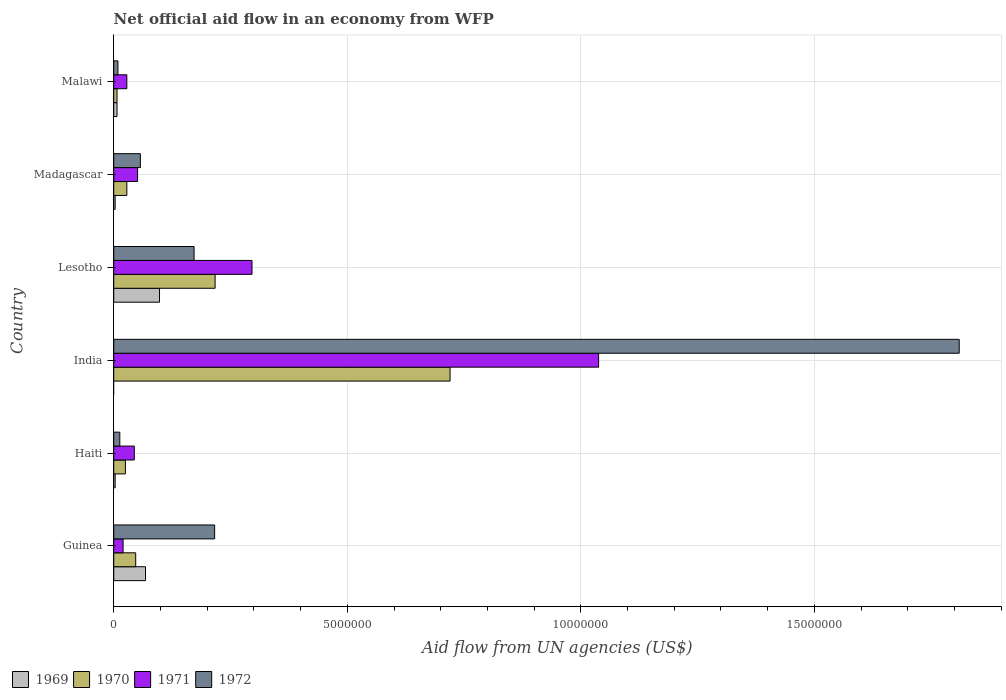Are the number of bars on each tick of the Y-axis equal?
Make the answer very short. No. How many bars are there on the 6th tick from the bottom?
Offer a terse response. 4. What is the label of the 2nd group of bars from the top?
Offer a terse response. Madagascar. In how many cases, is the number of bars for a given country not equal to the number of legend labels?
Your answer should be very brief. 1. Across all countries, what is the maximum net official aid flow in 1971?
Offer a very short reply. 1.04e+07. Across all countries, what is the minimum net official aid flow in 1970?
Provide a succinct answer. 7.00e+04. In which country was the net official aid flow in 1971 maximum?
Keep it short and to the point. India. What is the total net official aid flow in 1971 in the graph?
Your answer should be compact. 1.48e+07. What is the difference between the net official aid flow in 1972 in India and that in Malawi?
Provide a short and direct response. 1.80e+07. What is the average net official aid flow in 1972 per country?
Offer a terse response. 3.80e+06. What is the difference between the net official aid flow in 1971 and net official aid flow in 1972 in Guinea?
Your answer should be compact. -1.96e+06. What is the ratio of the net official aid flow in 1969 in Madagascar to that in Malawi?
Ensure brevity in your answer.  0.43. Is the net official aid flow in 1970 in Guinea less than that in Malawi?
Ensure brevity in your answer.  No. What is the difference between the highest and the second highest net official aid flow in 1972?
Your answer should be very brief. 1.59e+07. What is the difference between the highest and the lowest net official aid flow in 1969?
Your answer should be compact. 9.80e+05. How many countries are there in the graph?
Give a very brief answer. 6. Are the values on the major ticks of X-axis written in scientific E-notation?
Ensure brevity in your answer.  No. Does the graph contain grids?
Offer a terse response. Yes. How are the legend labels stacked?
Ensure brevity in your answer.  Horizontal. What is the title of the graph?
Offer a very short reply. Net official aid flow in an economy from WFP. Does "1972" appear as one of the legend labels in the graph?
Offer a terse response. Yes. What is the label or title of the X-axis?
Make the answer very short. Aid flow from UN agencies (US$). What is the Aid flow from UN agencies (US$) in 1969 in Guinea?
Provide a succinct answer. 6.80e+05. What is the Aid flow from UN agencies (US$) of 1971 in Guinea?
Your answer should be very brief. 2.00e+05. What is the Aid flow from UN agencies (US$) of 1972 in Guinea?
Provide a succinct answer. 2.16e+06. What is the Aid flow from UN agencies (US$) in 1969 in Haiti?
Make the answer very short. 3.00e+04. What is the Aid flow from UN agencies (US$) in 1971 in Haiti?
Keep it short and to the point. 4.40e+05. What is the Aid flow from UN agencies (US$) of 1972 in Haiti?
Make the answer very short. 1.30e+05. What is the Aid flow from UN agencies (US$) in 1969 in India?
Your answer should be compact. 0. What is the Aid flow from UN agencies (US$) of 1970 in India?
Make the answer very short. 7.20e+06. What is the Aid flow from UN agencies (US$) in 1971 in India?
Offer a very short reply. 1.04e+07. What is the Aid flow from UN agencies (US$) in 1972 in India?
Your answer should be compact. 1.81e+07. What is the Aid flow from UN agencies (US$) in 1969 in Lesotho?
Provide a short and direct response. 9.80e+05. What is the Aid flow from UN agencies (US$) in 1970 in Lesotho?
Your answer should be compact. 2.17e+06. What is the Aid flow from UN agencies (US$) in 1971 in Lesotho?
Ensure brevity in your answer.  2.96e+06. What is the Aid flow from UN agencies (US$) in 1972 in Lesotho?
Provide a short and direct response. 1.72e+06. What is the Aid flow from UN agencies (US$) of 1969 in Madagascar?
Your answer should be compact. 3.00e+04. What is the Aid flow from UN agencies (US$) of 1971 in Madagascar?
Ensure brevity in your answer.  5.10e+05. What is the Aid flow from UN agencies (US$) in 1972 in Madagascar?
Your answer should be compact. 5.70e+05. What is the Aid flow from UN agencies (US$) of 1970 in Malawi?
Ensure brevity in your answer.  7.00e+04. Across all countries, what is the maximum Aid flow from UN agencies (US$) in 1969?
Make the answer very short. 9.80e+05. Across all countries, what is the maximum Aid flow from UN agencies (US$) in 1970?
Ensure brevity in your answer.  7.20e+06. Across all countries, what is the maximum Aid flow from UN agencies (US$) in 1971?
Your response must be concise. 1.04e+07. Across all countries, what is the maximum Aid flow from UN agencies (US$) of 1972?
Your answer should be very brief. 1.81e+07. Across all countries, what is the minimum Aid flow from UN agencies (US$) of 1970?
Give a very brief answer. 7.00e+04. Across all countries, what is the minimum Aid flow from UN agencies (US$) of 1972?
Give a very brief answer. 9.00e+04. What is the total Aid flow from UN agencies (US$) of 1969 in the graph?
Keep it short and to the point. 1.79e+06. What is the total Aid flow from UN agencies (US$) in 1970 in the graph?
Make the answer very short. 1.04e+07. What is the total Aid flow from UN agencies (US$) in 1971 in the graph?
Ensure brevity in your answer.  1.48e+07. What is the total Aid flow from UN agencies (US$) of 1972 in the graph?
Offer a terse response. 2.28e+07. What is the difference between the Aid flow from UN agencies (US$) of 1969 in Guinea and that in Haiti?
Your answer should be compact. 6.50e+05. What is the difference between the Aid flow from UN agencies (US$) of 1970 in Guinea and that in Haiti?
Keep it short and to the point. 2.20e+05. What is the difference between the Aid flow from UN agencies (US$) of 1971 in Guinea and that in Haiti?
Your answer should be very brief. -2.40e+05. What is the difference between the Aid flow from UN agencies (US$) in 1972 in Guinea and that in Haiti?
Your answer should be compact. 2.03e+06. What is the difference between the Aid flow from UN agencies (US$) in 1970 in Guinea and that in India?
Offer a very short reply. -6.73e+06. What is the difference between the Aid flow from UN agencies (US$) of 1971 in Guinea and that in India?
Offer a terse response. -1.02e+07. What is the difference between the Aid flow from UN agencies (US$) in 1972 in Guinea and that in India?
Provide a succinct answer. -1.59e+07. What is the difference between the Aid flow from UN agencies (US$) in 1969 in Guinea and that in Lesotho?
Provide a succinct answer. -3.00e+05. What is the difference between the Aid flow from UN agencies (US$) in 1970 in Guinea and that in Lesotho?
Offer a very short reply. -1.70e+06. What is the difference between the Aid flow from UN agencies (US$) of 1971 in Guinea and that in Lesotho?
Make the answer very short. -2.76e+06. What is the difference between the Aid flow from UN agencies (US$) of 1972 in Guinea and that in Lesotho?
Ensure brevity in your answer.  4.40e+05. What is the difference between the Aid flow from UN agencies (US$) of 1969 in Guinea and that in Madagascar?
Your answer should be very brief. 6.50e+05. What is the difference between the Aid flow from UN agencies (US$) of 1970 in Guinea and that in Madagascar?
Offer a terse response. 1.90e+05. What is the difference between the Aid flow from UN agencies (US$) in 1971 in Guinea and that in Madagascar?
Offer a very short reply. -3.10e+05. What is the difference between the Aid flow from UN agencies (US$) in 1972 in Guinea and that in Madagascar?
Your answer should be compact. 1.59e+06. What is the difference between the Aid flow from UN agencies (US$) of 1969 in Guinea and that in Malawi?
Keep it short and to the point. 6.10e+05. What is the difference between the Aid flow from UN agencies (US$) of 1970 in Guinea and that in Malawi?
Ensure brevity in your answer.  4.00e+05. What is the difference between the Aid flow from UN agencies (US$) of 1971 in Guinea and that in Malawi?
Make the answer very short. -8.00e+04. What is the difference between the Aid flow from UN agencies (US$) of 1972 in Guinea and that in Malawi?
Provide a succinct answer. 2.07e+06. What is the difference between the Aid flow from UN agencies (US$) of 1970 in Haiti and that in India?
Your answer should be very brief. -6.95e+06. What is the difference between the Aid flow from UN agencies (US$) of 1971 in Haiti and that in India?
Offer a very short reply. -9.94e+06. What is the difference between the Aid flow from UN agencies (US$) of 1972 in Haiti and that in India?
Give a very brief answer. -1.80e+07. What is the difference between the Aid flow from UN agencies (US$) of 1969 in Haiti and that in Lesotho?
Ensure brevity in your answer.  -9.50e+05. What is the difference between the Aid flow from UN agencies (US$) of 1970 in Haiti and that in Lesotho?
Keep it short and to the point. -1.92e+06. What is the difference between the Aid flow from UN agencies (US$) of 1971 in Haiti and that in Lesotho?
Make the answer very short. -2.52e+06. What is the difference between the Aid flow from UN agencies (US$) of 1972 in Haiti and that in Lesotho?
Your answer should be very brief. -1.59e+06. What is the difference between the Aid flow from UN agencies (US$) of 1972 in Haiti and that in Madagascar?
Your answer should be compact. -4.40e+05. What is the difference between the Aid flow from UN agencies (US$) of 1970 in Haiti and that in Malawi?
Your response must be concise. 1.80e+05. What is the difference between the Aid flow from UN agencies (US$) in 1970 in India and that in Lesotho?
Offer a terse response. 5.03e+06. What is the difference between the Aid flow from UN agencies (US$) of 1971 in India and that in Lesotho?
Give a very brief answer. 7.42e+06. What is the difference between the Aid flow from UN agencies (US$) in 1972 in India and that in Lesotho?
Ensure brevity in your answer.  1.64e+07. What is the difference between the Aid flow from UN agencies (US$) in 1970 in India and that in Madagascar?
Provide a short and direct response. 6.92e+06. What is the difference between the Aid flow from UN agencies (US$) in 1971 in India and that in Madagascar?
Make the answer very short. 9.87e+06. What is the difference between the Aid flow from UN agencies (US$) in 1972 in India and that in Madagascar?
Your answer should be very brief. 1.75e+07. What is the difference between the Aid flow from UN agencies (US$) of 1970 in India and that in Malawi?
Provide a succinct answer. 7.13e+06. What is the difference between the Aid flow from UN agencies (US$) of 1971 in India and that in Malawi?
Offer a very short reply. 1.01e+07. What is the difference between the Aid flow from UN agencies (US$) in 1972 in India and that in Malawi?
Keep it short and to the point. 1.80e+07. What is the difference between the Aid flow from UN agencies (US$) in 1969 in Lesotho and that in Madagascar?
Your response must be concise. 9.50e+05. What is the difference between the Aid flow from UN agencies (US$) in 1970 in Lesotho and that in Madagascar?
Your answer should be compact. 1.89e+06. What is the difference between the Aid flow from UN agencies (US$) of 1971 in Lesotho and that in Madagascar?
Your answer should be very brief. 2.45e+06. What is the difference between the Aid flow from UN agencies (US$) of 1972 in Lesotho and that in Madagascar?
Ensure brevity in your answer.  1.15e+06. What is the difference between the Aid flow from UN agencies (US$) of 1969 in Lesotho and that in Malawi?
Offer a terse response. 9.10e+05. What is the difference between the Aid flow from UN agencies (US$) of 1970 in Lesotho and that in Malawi?
Provide a short and direct response. 2.10e+06. What is the difference between the Aid flow from UN agencies (US$) in 1971 in Lesotho and that in Malawi?
Provide a succinct answer. 2.68e+06. What is the difference between the Aid flow from UN agencies (US$) of 1972 in Lesotho and that in Malawi?
Offer a terse response. 1.63e+06. What is the difference between the Aid flow from UN agencies (US$) in 1970 in Madagascar and that in Malawi?
Give a very brief answer. 2.10e+05. What is the difference between the Aid flow from UN agencies (US$) of 1972 in Madagascar and that in Malawi?
Provide a short and direct response. 4.80e+05. What is the difference between the Aid flow from UN agencies (US$) in 1969 in Guinea and the Aid flow from UN agencies (US$) in 1970 in Haiti?
Your answer should be very brief. 4.30e+05. What is the difference between the Aid flow from UN agencies (US$) of 1970 in Guinea and the Aid flow from UN agencies (US$) of 1971 in Haiti?
Your response must be concise. 3.00e+04. What is the difference between the Aid flow from UN agencies (US$) in 1970 in Guinea and the Aid flow from UN agencies (US$) in 1972 in Haiti?
Provide a short and direct response. 3.40e+05. What is the difference between the Aid flow from UN agencies (US$) of 1971 in Guinea and the Aid flow from UN agencies (US$) of 1972 in Haiti?
Provide a succinct answer. 7.00e+04. What is the difference between the Aid flow from UN agencies (US$) in 1969 in Guinea and the Aid flow from UN agencies (US$) in 1970 in India?
Ensure brevity in your answer.  -6.52e+06. What is the difference between the Aid flow from UN agencies (US$) in 1969 in Guinea and the Aid flow from UN agencies (US$) in 1971 in India?
Provide a short and direct response. -9.70e+06. What is the difference between the Aid flow from UN agencies (US$) in 1969 in Guinea and the Aid flow from UN agencies (US$) in 1972 in India?
Your response must be concise. -1.74e+07. What is the difference between the Aid flow from UN agencies (US$) in 1970 in Guinea and the Aid flow from UN agencies (US$) in 1971 in India?
Provide a succinct answer. -9.91e+06. What is the difference between the Aid flow from UN agencies (US$) of 1970 in Guinea and the Aid flow from UN agencies (US$) of 1972 in India?
Your response must be concise. -1.76e+07. What is the difference between the Aid flow from UN agencies (US$) of 1971 in Guinea and the Aid flow from UN agencies (US$) of 1972 in India?
Give a very brief answer. -1.79e+07. What is the difference between the Aid flow from UN agencies (US$) in 1969 in Guinea and the Aid flow from UN agencies (US$) in 1970 in Lesotho?
Your answer should be very brief. -1.49e+06. What is the difference between the Aid flow from UN agencies (US$) of 1969 in Guinea and the Aid flow from UN agencies (US$) of 1971 in Lesotho?
Give a very brief answer. -2.28e+06. What is the difference between the Aid flow from UN agencies (US$) in 1969 in Guinea and the Aid flow from UN agencies (US$) in 1972 in Lesotho?
Offer a terse response. -1.04e+06. What is the difference between the Aid flow from UN agencies (US$) of 1970 in Guinea and the Aid flow from UN agencies (US$) of 1971 in Lesotho?
Your answer should be very brief. -2.49e+06. What is the difference between the Aid flow from UN agencies (US$) of 1970 in Guinea and the Aid flow from UN agencies (US$) of 1972 in Lesotho?
Provide a succinct answer. -1.25e+06. What is the difference between the Aid flow from UN agencies (US$) in 1971 in Guinea and the Aid flow from UN agencies (US$) in 1972 in Lesotho?
Offer a terse response. -1.52e+06. What is the difference between the Aid flow from UN agencies (US$) in 1969 in Guinea and the Aid flow from UN agencies (US$) in 1970 in Madagascar?
Your answer should be compact. 4.00e+05. What is the difference between the Aid flow from UN agencies (US$) in 1970 in Guinea and the Aid flow from UN agencies (US$) in 1971 in Madagascar?
Give a very brief answer. -4.00e+04. What is the difference between the Aid flow from UN agencies (US$) in 1970 in Guinea and the Aid flow from UN agencies (US$) in 1972 in Madagascar?
Your answer should be compact. -1.00e+05. What is the difference between the Aid flow from UN agencies (US$) in 1971 in Guinea and the Aid flow from UN agencies (US$) in 1972 in Madagascar?
Keep it short and to the point. -3.70e+05. What is the difference between the Aid flow from UN agencies (US$) of 1969 in Guinea and the Aid flow from UN agencies (US$) of 1972 in Malawi?
Offer a terse response. 5.90e+05. What is the difference between the Aid flow from UN agencies (US$) in 1970 in Guinea and the Aid flow from UN agencies (US$) in 1972 in Malawi?
Give a very brief answer. 3.80e+05. What is the difference between the Aid flow from UN agencies (US$) of 1971 in Guinea and the Aid flow from UN agencies (US$) of 1972 in Malawi?
Provide a succinct answer. 1.10e+05. What is the difference between the Aid flow from UN agencies (US$) of 1969 in Haiti and the Aid flow from UN agencies (US$) of 1970 in India?
Provide a short and direct response. -7.17e+06. What is the difference between the Aid flow from UN agencies (US$) in 1969 in Haiti and the Aid flow from UN agencies (US$) in 1971 in India?
Offer a terse response. -1.04e+07. What is the difference between the Aid flow from UN agencies (US$) of 1969 in Haiti and the Aid flow from UN agencies (US$) of 1972 in India?
Your answer should be very brief. -1.81e+07. What is the difference between the Aid flow from UN agencies (US$) of 1970 in Haiti and the Aid flow from UN agencies (US$) of 1971 in India?
Give a very brief answer. -1.01e+07. What is the difference between the Aid flow from UN agencies (US$) in 1970 in Haiti and the Aid flow from UN agencies (US$) in 1972 in India?
Provide a short and direct response. -1.78e+07. What is the difference between the Aid flow from UN agencies (US$) of 1971 in Haiti and the Aid flow from UN agencies (US$) of 1972 in India?
Give a very brief answer. -1.77e+07. What is the difference between the Aid flow from UN agencies (US$) of 1969 in Haiti and the Aid flow from UN agencies (US$) of 1970 in Lesotho?
Your answer should be very brief. -2.14e+06. What is the difference between the Aid flow from UN agencies (US$) of 1969 in Haiti and the Aid flow from UN agencies (US$) of 1971 in Lesotho?
Your response must be concise. -2.93e+06. What is the difference between the Aid flow from UN agencies (US$) in 1969 in Haiti and the Aid flow from UN agencies (US$) in 1972 in Lesotho?
Provide a short and direct response. -1.69e+06. What is the difference between the Aid flow from UN agencies (US$) of 1970 in Haiti and the Aid flow from UN agencies (US$) of 1971 in Lesotho?
Your response must be concise. -2.71e+06. What is the difference between the Aid flow from UN agencies (US$) in 1970 in Haiti and the Aid flow from UN agencies (US$) in 1972 in Lesotho?
Ensure brevity in your answer.  -1.47e+06. What is the difference between the Aid flow from UN agencies (US$) in 1971 in Haiti and the Aid flow from UN agencies (US$) in 1972 in Lesotho?
Keep it short and to the point. -1.28e+06. What is the difference between the Aid flow from UN agencies (US$) of 1969 in Haiti and the Aid flow from UN agencies (US$) of 1971 in Madagascar?
Your answer should be very brief. -4.80e+05. What is the difference between the Aid flow from UN agencies (US$) of 1969 in Haiti and the Aid flow from UN agencies (US$) of 1972 in Madagascar?
Your answer should be compact. -5.40e+05. What is the difference between the Aid flow from UN agencies (US$) in 1970 in Haiti and the Aid flow from UN agencies (US$) in 1972 in Madagascar?
Offer a very short reply. -3.20e+05. What is the difference between the Aid flow from UN agencies (US$) in 1971 in Haiti and the Aid flow from UN agencies (US$) in 1972 in Madagascar?
Your answer should be very brief. -1.30e+05. What is the difference between the Aid flow from UN agencies (US$) in 1969 in Haiti and the Aid flow from UN agencies (US$) in 1971 in Malawi?
Ensure brevity in your answer.  -2.50e+05. What is the difference between the Aid flow from UN agencies (US$) in 1969 in Haiti and the Aid flow from UN agencies (US$) in 1972 in Malawi?
Provide a short and direct response. -6.00e+04. What is the difference between the Aid flow from UN agencies (US$) in 1970 in Haiti and the Aid flow from UN agencies (US$) in 1972 in Malawi?
Provide a short and direct response. 1.60e+05. What is the difference between the Aid flow from UN agencies (US$) of 1970 in India and the Aid flow from UN agencies (US$) of 1971 in Lesotho?
Provide a succinct answer. 4.24e+06. What is the difference between the Aid flow from UN agencies (US$) of 1970 in India and the Aid flow from UN agencies (US$) of 1972 in Lesotho?
Provide a succinct answer. 5.48e+06. What is the difference between the Aid flow from UN agencies (US$) in 1971 in India and the Aid flow from UN agencies (US$) in 1972 in Lesotho?
Offer a terse response. 8.66e+06. What is the difference between the Aid flow from UN agencies (US$) in 1970 in India and the Aid flow from UN agencies (US$) in 1971 in Madagascar?
Your answer should be very brief. 6.69e+06. What is the difference between the Aid flow from UN agencies (US$) of 1970 in India and the Aid flow from UN agencies (US$) of 1972 in Madagascar?
Ensure brevity in your answer.  6.63e+06. What is the difference between the Aid flow from UN agencies (US$) in 1971 in India and the Aid flow from UN agencies (US$) in 1972 in Madagascar?
Make the answer very short. 9.81e+06. What is the difference between the Aid flow from UN agencies (US$) in 1970 in India and the Aid flow from UN agencies (US$) in 1971 in Malawi?
Give a very brief answer. 6.92e+06. What is the difference between the Aid flow from UN agencies (US$) in 1970 in India and the Aid flow from UN agencies (US$) in 1972 in Malawi?
Your answer should be very brief. 7.11e+06. What is the difference between the Aid flow from UN agencies (US$) in 1971 in India and the Aid flow from UN agencies (US$) in 1972 in Malawi?
Offer a very short reply. 1.03e+07. What is the difference between the Aid flow from UN agencies (US$) of 1969 in Lesotho and the Aid flow from UN agencies (US$) of 1970 in Madagascar?
Provide a short and direct response. 7.00e+05. What is the difference between the Aid flow from UN agencies (US$) in 1970 in Lesotho and the Aid flow from UN agencies (US$) in 1971 in Madagascar?
Your answer should be very brief. 1.66e+06. What is the difference between the Aid flow from UN agencies (US$) of 1970 in Lesotho and the Aid flow from UN agencies (US$) of 1972 in Madagascar?
Offer a very short reply. 1.60e+06. What is the difference between the Aid flow from UN agencies (US$) in 1971 in Lesotho and the Aid flow from UN agencies (US$) in 1972 in Madagascar?
Your answer should be very brief. 2.39e+06. What is the difference between the Aid flow from UN agencies (US$) of 1969 in Lesotho and the Aid flow from UN agencies (US$) of 1970 in Malawi?
Your answer should be very brief. 9.10e+05. What is the difference between the Aid flow from UN agencies (US$) in 1969 in Lesotho and the Aid flow from UN agencies (US$) in 1971 in Malawi?
Provide a succinct answer. 7.00e+05. What is the difference between the Aid flow from UN agencies (US$) of 1969 in Lesotho and the Aid flow from UN agencies (US$) of 1972 in Malawi?
Offer a terse response. 8.90e+05. What is the difference between the Aid flow from UN agencies (US$) in 1970 in Lesotho and the Aid flow from UN agencies (US$) in 1971 in Malawi?
Offer a very short reply. 1.89e+06. What is the difference between the Aid flow from UN agencies (US$) of 1970 in Lesotho and the Aid flow from UN agencies (US$) of 1972 in Malawi?
Keep it short and to the point. 2.08e+06. What is the difference between the Aid flow from UN agencies (US$) of 1971 in Lesotho and the Aid flow from UN agencies (US$) of 1972 in Malawi?
Offer a very short reply. 2.87e+06. What is the difference between the Aid flow from UN agencies (US$) in 1969 in Madagascar and the Aid flow from UN agencies (US$) in 1970 in Malawi?
Your response must be concise. -4.00e+04. What is the difference between the Aid flow from UN agencies (US$) of 1969 in Madagascar and the Aid flow from UN agencies (US$) of 1971 in Malawi?
Offer a very short reply. -2.50e+05. What is the difference between the Aid flow from UN agencies (US$) of 1970 in Madagascar and the Aid flow from UN agencies (US$) of 1971 in Malawi?
Offer a terse response. 0. What is the difference between the Aid flow from UN agencies (US$) in 1970 in Madagascar and the Aid flow from UN agencies (US$) in 1972 in Malawi?
Your answer should be very brief. 1.90e+05. What is the average Aid flow from UN agencies (US$) in 1969 per country?
Ensure brevity in your answer.  2.98e+05. What is the average Aid flow from UN agencies (US$) of 1970 per country?
Provide a succinct answer. 1.74e+06. What is the average Aid flow from UN agencies (US$) of 1971 per country?
Keep it short and to the point. 2.46e+06. What is the average Aid flow from UN agencies (US$) of 1972 per country?
Ensure brevity in your answer.  3.80e+06. What is the difference between the Aid flow from UN agencies (US$) in 1969 and Aid flow from UN agencies (US$) in 1972 in Guinea?
Provide a short and direct response. -1.48e+06. What is the difference between the Aid flow from UN agencies (US$) of 1970 and Aid flow from UN agencies (US$) of 1971 in Guinea?
Your answer should be compact. 2.70e+05. What is the difference between the Aid flow from UN agencies (US$) in 1970 and Aid flow from UN agencies (US$) in 1972 in Guinea?
Your answer should be compact. -1.69e+06. What is the difference between the Aid flow from UN agencies (US$) of 1971 and Aid flow from UN agencies (US$) of 1972 in Guinea?
Give a very brief answer. -1.96e+06. What is the difference between the Aid flow from UN agencies (US$) in 1969 and Aid flow from UN agencies (US$) in 1970 in Haiti?
Offer a terse response. -2.20e+05. What is the difference between the Aid flow from UN agencies (US$) of 1969 and Aid flow from UN agencies (US$) of 1971 in Haiti?
Your answer should be very brief. -4.10e+05. What is the difference between the Aid flow from UN agencies (US$) in 1970 and Aid flow from UN agencies (US$) in 1972 in Haiti?
Ensure brevity in your answer.  1.20e+05. What is the difference between the Aid flow from UN agencies (US$) of 1971 and Aid flow from UN agencies (US$) of 1972 in Haiti?
Your answer should be very brief. 3.10e+05. What is the difference between the Aid flow from UN agencies (US$) of 1970 and Aid flow from UN agencies (US$) of 1971 in India?
Provide a succinct answer. -3.18e+06. What is the difference between the Aid flow from UN agencies (US$) in 1970 and Aid flow from UN agencies (US$) in 1972 in India?
Provide a succinct answer. -1.09e+07. What is the difference between the Aid flow from UN agencies (US$) of 1971 and Aid flow from UN agencies (US$) of 1972 in India?
Your answer should be very brief. -7.72e+06. What is the difference between the Aid flow from UN agencies (US$) of 1969 and Aid flow from UN agencies (US$) of 1970 in Lesotho?
Provide a succinct answer. -1.19e+06. What is the difference between the Aid flow from UN agencies (US$) of 1969 and Aid flow from UN agencies (US$) of 1971 in Lesotho?
Provide a short and direct response. -1.98e+06. What is the difference between the Aid flow from UN agencies (US$) in 1969 and Aid flow from UN agencies (US$) in 1972 in Lesotho?
Your answer should be compact. -7.40e+05. What is the difference between the Aid flow from UN agencies (US$) in 1970 and Aid flow from UN agencies (US$) in 1971 in Lesotho?
Offer a very short reply. -7.90e+05. What is the difference between the Aid flow from UN agencies (US$) in 1971 and Aid flow from UN agencies (US$) in 1972 in Lesotho?
Ensure brevity in your answer.  1.24e+06. What is the difference between the Aid flow from UN agencies (US$) of 1969 and Aid flow from UN agencies (US$) of 1971 in Madagascar?
Your response must be concise. -4.80e+05. What is the difference between the Aid flow from UN agencies (US$) of 1969 and Aid flow from UN agencies (US$) of 1972 in Madagascar?
Offer a terse response. -5.40e+05. What is the difference between the Aid flow from UN agencies (US$) in 1970 and Aid flow from UN agencies (US$) in 1972 in Madagascar?
Your response must be concise. -2.90e+05. What is the difference between the Aid flow from UN agencies (US$) in 1971 and Aid flow from UN agencies (US$) in 1972 in Madagascar?
Ensure brevity in your answer.  -6.00e+04. What is the difference between the Aid flow from UN agencies (US$) in 1969 and Aid flow from UN agencies (US$) in 1972 in Malawi?
Your response must be concise. -2.00e+04. What is the difference between the Aid flow from UN agencies (US$) of 1970 and Aid flow from UN agencies (US$) of 1971 in Malawi?
Offer a very short reply. -2.10e+05. What is the ratio of the Aid flow from UN agencies (US$) of 1969 in Guinea to that in Haiti?
Offer a terse response. 22.67. What is the ratio of the Aid flow from UN agencies (US$) in 1970 in Guinea to that in Haiti?
Provide a short and direct response. 1.88. What is the ratio of the Aid flow from UN agencies (US$) of 1971 in Guinea to that in Haiti?
Your answer should be compact. 0.45. What is the ratio of the Aid flow from UN agencies (US$) of 1972 in Guinea to that in Haiti?
Offer a very short reply. 16.62. What is the ratio of the Aid flow from UN agencies (US$) in 1970 in Guinea to that in India?
Offer a terse response. 0.07. What is the ratio of the Aid flow from UN agencies (US$) in 1971 in Guinea to that in India?
Your answer should be very brief. 0.02. What is the ratio of the Aid flow from UN agencies (US$) in 1972 in Guinea to that in India?
Offer a very short reply. 0.12. What is the ratio of the Aid flow from UN agencies (US$) of 1969 in Guinea to that in Lesotho?
Offer a terse response. 0.69. What is the ratio of the Aid flow from UN agencies (US$) in 1970 in Guinea to that in Lesotho?
Provide a short and direct response. 0.22. What is the ratio of the Aid flow from UN agencies (US$) in 1971 in Guinea to that in Lesotho?
Give a very brief answer. 0.07. What is the ratio of the Aid flow from UN agencies (US$) in 1972 in Guinea to that in Lesotho?
Your answer should be very brief. 1.26. What is the ratio of the Aid flow from UN agencies (US$) in 1969 in Guinea to that in Madagascar?
Keep it short and to the point. 22.67. What is the ratio of the Aid flow from UN agencies (US$) in 1970 in Guinea to that in Madagascar?
Your answer should be very brief. 1.68. What is the ratio of the Aid flow from UN agencies (US$) of 1971 in Guinea to that in Madagascar?
Keep it short and to the point. 0.39. What is the ratio of the Aid flow from UN agencies (US$) of 1972 in Guinea to that in Madagascar?
Offer a terse response. 3.79. What is the ratio of the Aid flow from UN agencies (US$) in 1969 in Guinea to that in Malawi?
Provide a short and direct response. 9.71. What is the ratio of the Aid flow from UN agencies (US$) in 1970 in Guinea to that in Malawi?
Keep it short and to the point. 6.71. What is the ratio of the Aid flow from UN agencies (US$) in 1971 in Guinea to that in Malawi?
Provide a succinct answer. 0.71. What is the ratio of the Aid flow from UN agencies (US$) of 1970 in Haiti to that in India?
Your answer should be compact. 0.03. What is the ratio of the Aid flow from UN agencies (US$) in 1971 in Haiti to that in India?
Offer a very short reply. 0.04. What is the ratio of the Aid flow from UN agencies (US$) of 1972 in Haiti to that in India?
Provide a short and direct response. 0.01. What is the ratio of the Aid flow from UN agencies (US$) in 1969 in Haiti to that in Lesotho?
Give a very brief answer. 0.03. What is the ratio of the Aid flow from UN agencies (US$) of 1970 in Haiti to that in Lesotho?
Keep it short and to the point. 0.12. What is the ratio of the Aid flow from UN agencies (US$) in 1971 in Haiti to that in Lesotho?
Provide a short and direct response. 0.15. What is the ratio of the Aid flow from UN agencies (US$) in 1972 in Haiti to that in Lesotho?
Ensure brevity in your answer.  0.08. What is the ratio of the Aid flow from UN agencies (US$) of 1970 in Haiti to that in Madagascar?
Keep it short and to the point. 0.89. What is the ratio of the Aid flow from UN agencies (US$) in 1971 in Haiti to that in Madagascar?
Offer a terse response. 0.86. What is the ratio of the Aid flow from UN agencies (US$) of 1972 in Haiti to that in Madagascar?
Give a very brief answer. 0.23. What is the ratio of the Aid flow from UN agencies (US$) in 1969 in Haiti to that in Malawi?
Your answer should be very brief. 0.43. What is the ratio of the Aid flow from UN agencies (US$) in 1970 in Haiti to that in Malawi?
Keep it short and to the point. 3.57. What is the ratio of the Aid flow from UN agencies (US$) in 1971 in Haiti to that in Malawi?
Offer a very short reply. 1.57. What is the ratio of the Aid flow from UN agencies (US$) of 1972 in Haiti to that in Malawi?
Provide a short and direct response. 1.44. What is the ratio of the Aid flow from UN agencies (US$) of 1970 in India to that in Lesotho?
Your answer should be very brief. 3.32. What is the ratio of the Aid flow from UN agencies (US$) in 1971 in India to that in Lesotho?
Provide a short and direct response. 3.51. What is the ratio of the Aid flow from UN agencies (US$) in 1972 in India to that in Lesotho?
Ensure brevity in your answer.  10.52. What is the ratio of the Aid flow from UN agencies (US$) in 1970 in India to that in Madagascar?
Your answer should be compact. 25.71. What is the ratio of the Aid flow from UN agencies (US$) in 1971 in India to that in Madagascar?
Provide a succinct answer. 20.35. What is the ratio of the Aid flow from UN agencies (US$) of 1972 in India to that in Madagascar?
Make the answer very short. 31.75. What is the ratio of the Aid flow from UN agencies (US$) in 1970 in India to that in Malawi?
Ensure brevity in your answer.  102.86. What is the ratio of the Aid flow from UN agencies (US$) in 1971 in India to that in Malawi?
Offer a terse response. 37.07. What is the ratio of the Aid flow from UN agencies (US$) in 1972 in India to that in Malawi?
Provide a short and direct response. 201.11. What is the ratio of the Aid flow from UN agencies (US$) in 1969 in Lesotho to that in Madagascar?
Keep it short and to the point. 32.67. What is the ratio of the Aid flow from UN agencies (US$) of 1970 in Lesotho to that in Madagascar?
Your response must be concise. 7.75. What is the ratio of the Aid flow from UN agencies (US$) in 1971 in Lesotho to that in Madagascar?
Give a very brief answer. 5.8. What is the ratio of the Aid flow from UN agencies (US$) of 1972 in Lesotho to that in Madagascar?
Give a very brief answer. 3.02. What is the ratio of the Aid flow from UN agencies (US$) of 1971 in Lesotho to that in Malawi?
Provide a succinct answer. 10.57. What is the ratio of the Aid flow from UN agencies (US$) of 1972 in Lesotho to that in Malawi?
Keep it short and to the point. 19.11. What is the ratio of the Aid flow from UN agencies (US$) in 1969 in Madagascar to that in Malawi?
Keep it short and to the point. 0.43. What is the ratio of the Aid flow from UN agencies (US$) of 1971 in Madagascar to that in Malawi?
Provide a short and direct response. 1.82. What is the ratio of the Aid flow from UN agencies (US$) of 1972 in Madagascar to that in Malawi?
Your answer should be compact. 6.33. What is the difference between the highest and the second highest Aid flow from UN agencies (US$) in 1969?
Your answer should be very brief. 3.00e+05. What is the difference between the highest and the second highest Aid flow from UN agencies (US$) of 1970?
Provide a short and direct response. 5.03e+06. What is the difference between the highest and the second highest Aid flow from UN agencies (US$) in 1971?
Ensure brevity in your answer.  7.42e+06. What is the difference between the highest and the second highest Aid flow from UN agencies (US$) of 1972?
Your answer should be very brief. 1.59e+07. What is the difference between the highest and the lowest Aid flow from UN agencies (US$) in 1969?
Your response must be concise. 9.80e+05. What is the difference between the highest and the lowest Aid flow from UN agencies (US$) of 1970?
Your answer should be compact. 7.13e+06. What is the difference between the highest and the lowest Aid flow from UN agencies (US$) of 1971?
Your answer should be very brief. 1.02e+07. What is the difference between the highest and the lowest Aid flow from UN agencies (US$) in 1972?
Give a very brief answer. 1.80e+07. 